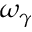<formula> <loc_0><loc_0><loc_500><loc_500>\omega _ { \gamma }</formula> 